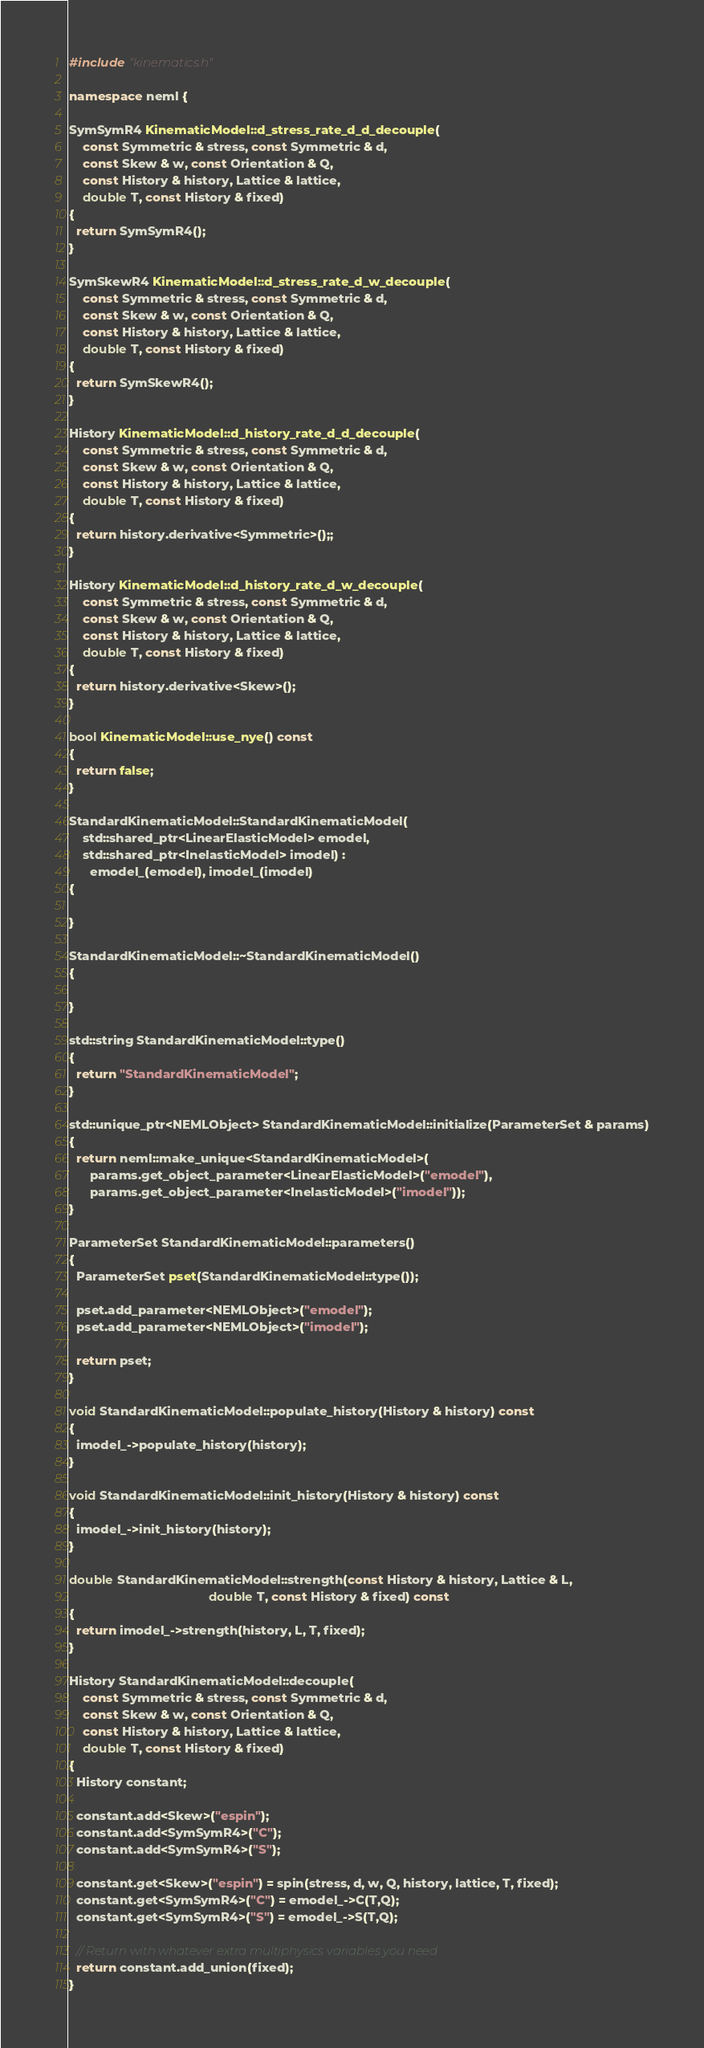<code> <loc_0><loc_0><loc_500><loc_500><_C++_>#include "kinematics.h"

namespace neml {

SymSymR4 KinematicModel::d_stress_rate_d_d_decouple(
    const Symmetric & stress, const Symmetric & d,
    const Skew & w, const Orientation & Q,
    const History & history, Lattice & lattice,
    double T, const History & fixed)
{
  return SymSymR4();
}

SymSkewR4 KinematicModel::d_stress_rate_d_w_decouple(
    const Symmetric & stress, const Symmetric & d,
    const Skew & w, const Orientation & Q,
    const History & history, Lattice & lattice,
    double T, const History & fixed)
{
  return SymSkewR4();
}

History KinematicModel::d_history_rate_d_d_decouple(
    const Symmetric & stress, const Symmetric & d,
    const Skew & w, const Orientation & Q,
    const History & history, Lattice & lattice,
    double T, const History & fixed)
{
  return history.derivative<Symmetric>();;
}

History KinematicModel::d_history_rate_d_w_decouple(
    const Symmetric & stress, const Symmetric & d,
    const Skew & w, const Orientation & Q,
    const History & history, Lattice & lattice,
    double T, const History & fixed)
{
  return history.derivative<Skew>();
}

bool KinematicModel::use_nye() const
{
  return false;
}

StandardKinematicModel::StandardKinematicModel(
    std::shared_ptr<LinearElasticModel> emodel,
    std::shared_ptr<InelasticModel> imodel) :
      emodel_(emodel), imodel_(imodel)
{

}

StandardKinematicModel::~StandardKinematicModel()
{

}

std::string StandardKinematicModel::type()
{
  return "StandardKinematicModel";
}

std::unique_ptr<NEMLObject> StandardKinematicModel::initialize(ParameterSet & params)
{
  return neml::make_unique<StandardKinematicModel>(
      params.get_object_parameter<LinearElasticModel>("emodel"),
      params.get_object_parameter<InelasticModel>("imodel"));
}

ParameterSet StandardKinematicModel::parameters()
{
  ParameterSet pset(StandardKinematicModel::type());
  
  pset.add_parameter<NEMLObject>("emodel");
  pset.add_parameter<NEMLObject>("imodel");

  return pset;
}

void StandardKinematicModel::populate_history(History & history) const
{
  imodel_->populate_history(history);
}

void StandardKinematicModel::init_history(History & history) const
{
  imodel_->init_history(history);
}

double StandardKinematicModel::strength(const History & history, Lattice & L,
                                        double T, const History & fixed) const
{
  return imodel_->strength(history, L, T, fixed);
}

History StandardKinematicModel::decouple(
    const Symmetric & stress, const Symmetric & d,
    const Skew & w, const Orientation & Q,
    const History & history, Lattice & lattice,
    double T, const History & fixed)
{
  History constant;

  constant.add<Skew>("espin");
  constant.add<SymSymR4>("C");
  constant.add<SymSymR4>("S");

  constant.get<Skew>("espin") = spin(stress, d, w, Q, history, lattice, T, fixed);
  constant.get<SymSymR4>("C") = emodel_->C(T,Q);
  constant.get<SymSymR4>("S") = emodel_->S(T,Q);
  
  // Return with whatever extra multiphysics variables you need
  return constant.add_union(fixed);
}
</code> 